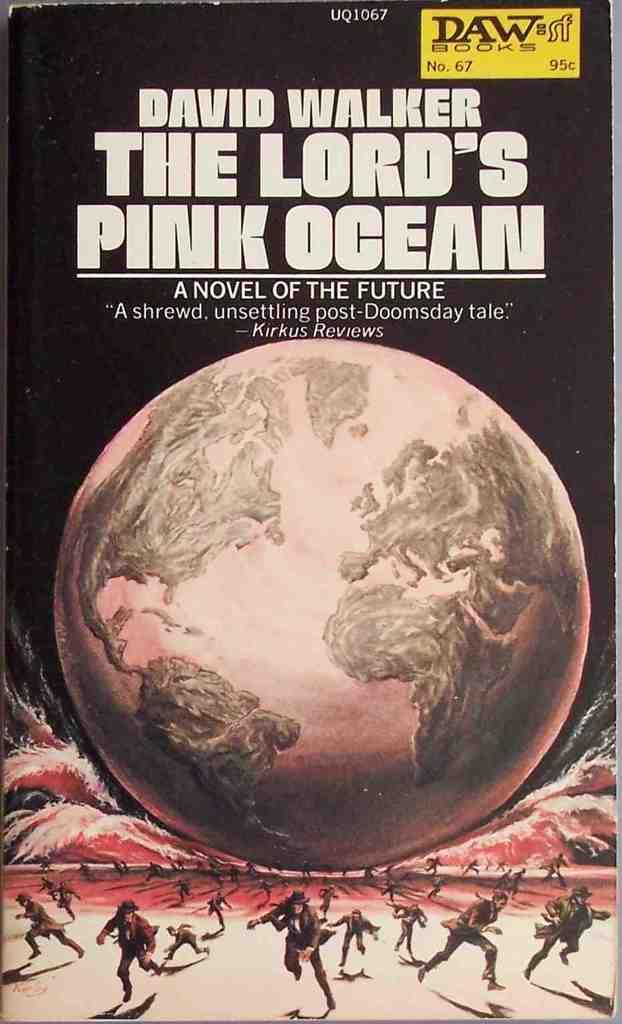<image>
Provide a brief description of the given image. the lord pink ocean that is on a cover 